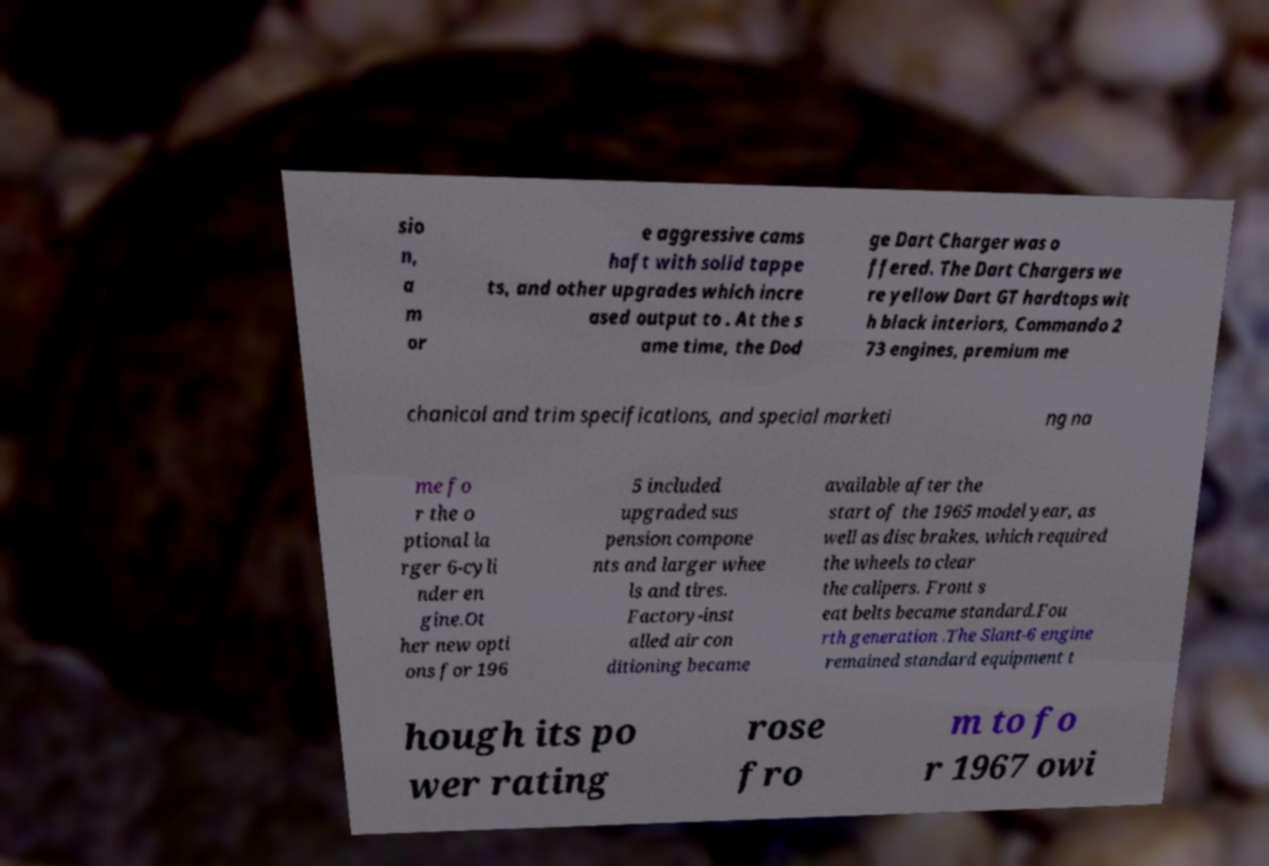What messages or text are displayed in this image? I need them in a readable, typed format. sio n, a m or e aggressive cams haft with solid tappe ts, and other upgrades which incre ased output to . At the s ame time, the Dod ge Dart Charger was o ffered. The Dart Chargers we re yellow Dart GT hardtops wit h black interiors, Commando 2 73 engines, premium me chanical and trim specifications, and special marketi ng na me fo r the o ptional la rger 6-cyli nder en gine.Ot her new opti ons for 196 5 included upgraded sus pension compone nts and larger whee ls and tires. Factory-inst alled air con ditioning became available after the start of the 1965 model year, as well as disc brakes, which required the wheels to clear the calipers. Front s eat belts became standard.Fou rth generation .The Slant-6 engine remained standard equipment t hough its po wer rating rose fro m to fo r 1967 owi 